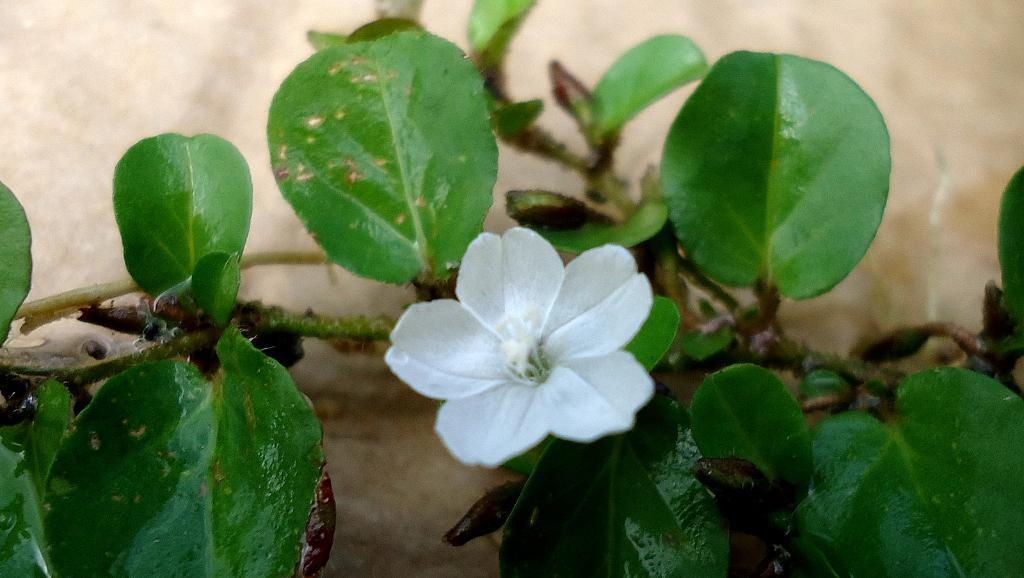What type of flower is in the image? There is a white color flower in the image. What else can be seen in the image besides the flower? There are leaves in the image. Can you describe the background of the image? The background of the image is blurry. Are there any wax sculptures visible in the image? There are no wax sculptures present in the image. What type of cactus can be seen growing in the background of the image? There is no cactus present in the image; it features a white color flower and leaves. 